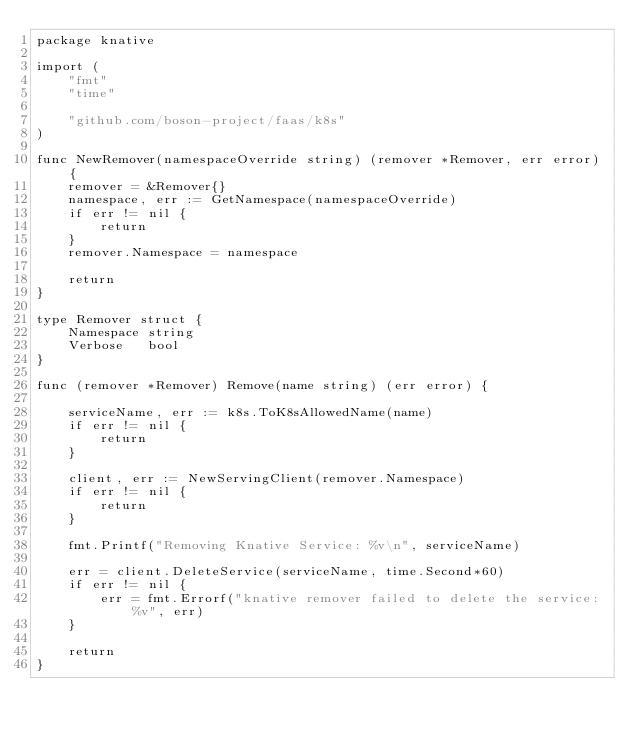<code> <loc_0><loc_0><loc_500><loc_500><_Go_>package knative

import (
	"fmt"
	"time"

	"github.com/boson-project/faas/k8s"
)

func NewRemover(namespaceOverride string) (remover *Remover, err error) {
	remover = &Remover{}
	namespace, err := GetNamespace(namespaceOverride)
	if err != nil {
		return
	}
	remover.Namespace = namespace

	return
}

type Remover struct {
	Namespace string
	Verbose   bool
}

func (remover *Remover) Remove(name string) (err error) {

	serviceName, err := k8s.ToK8sAllowedName(name)
	if err != nil {
		return
	}

	client, err := NewServingClient(remover.Namespace)
	if err != nil {
		return
	}

	fmt.Printf("Removing Knative Service: %v\n", serviceName)
	
	err = client.DeleteService(serviceName, time.Second*60)
	if err != nil {
		err = fmt.Errorf("knative remover failed to delete the service: %v", err)
	}

	return
}
</code> 